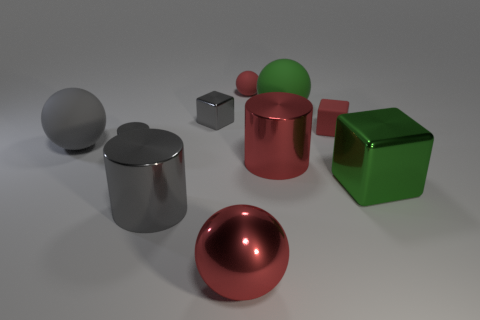Subtract all blocks. How many objects are left? 7 Add 5 gray matte balls. How many gray matte balls exist? 6 Subtract 0 purple blocks. How many objects are left? 10 Subtract all blue metal cylinders. Subtract all green metallic things. How many objects are left? 9 Add 4 big gray cylinders. How many big gray cylinders are left? 5 